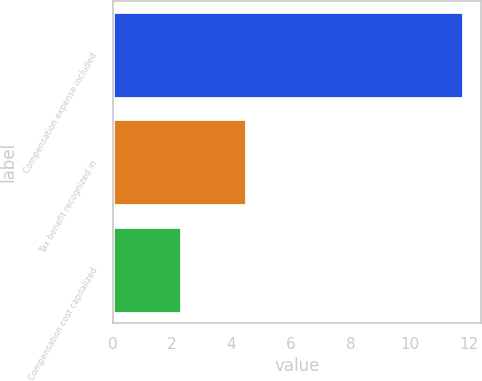Convert chart. <chart><loc_0><loc_0><loc_500><loc_500><bar_chart><fcel>Compensation expense included<fcel>Tax benefit recognized in<fcel>Compensation cost capitalized<nl><fcel>11.8<fcel>4.5<fcel>2.3<nl></chart> 